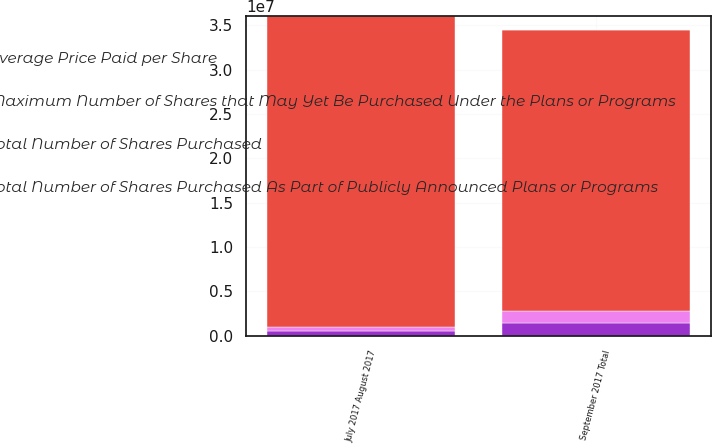<chart> <loc_0><loc_0><loc_500><loc_500><stacked_bar_chart><ecel><fcel>July 2017 August 2017<fcel>September 2017 Total<nl><fcel>Average Price Paid per Share<fcel>510690<fcel>1.4058e+06<nl><fcel>Total Number of Shares Purchased As Part of Publicly Announced Plans or Programs<fcel>45.75<fcel>42.67<nl><fcel>Maximum Number of Shares that May Yet Be Purchased Under the Plans or Programs<fcel>510690<fcel>1.4058e+06<nl><fcel>Total Number of Shares Purchased<fcel>3.49996e+07<fcel>3.16235e+07<nl></chart> 